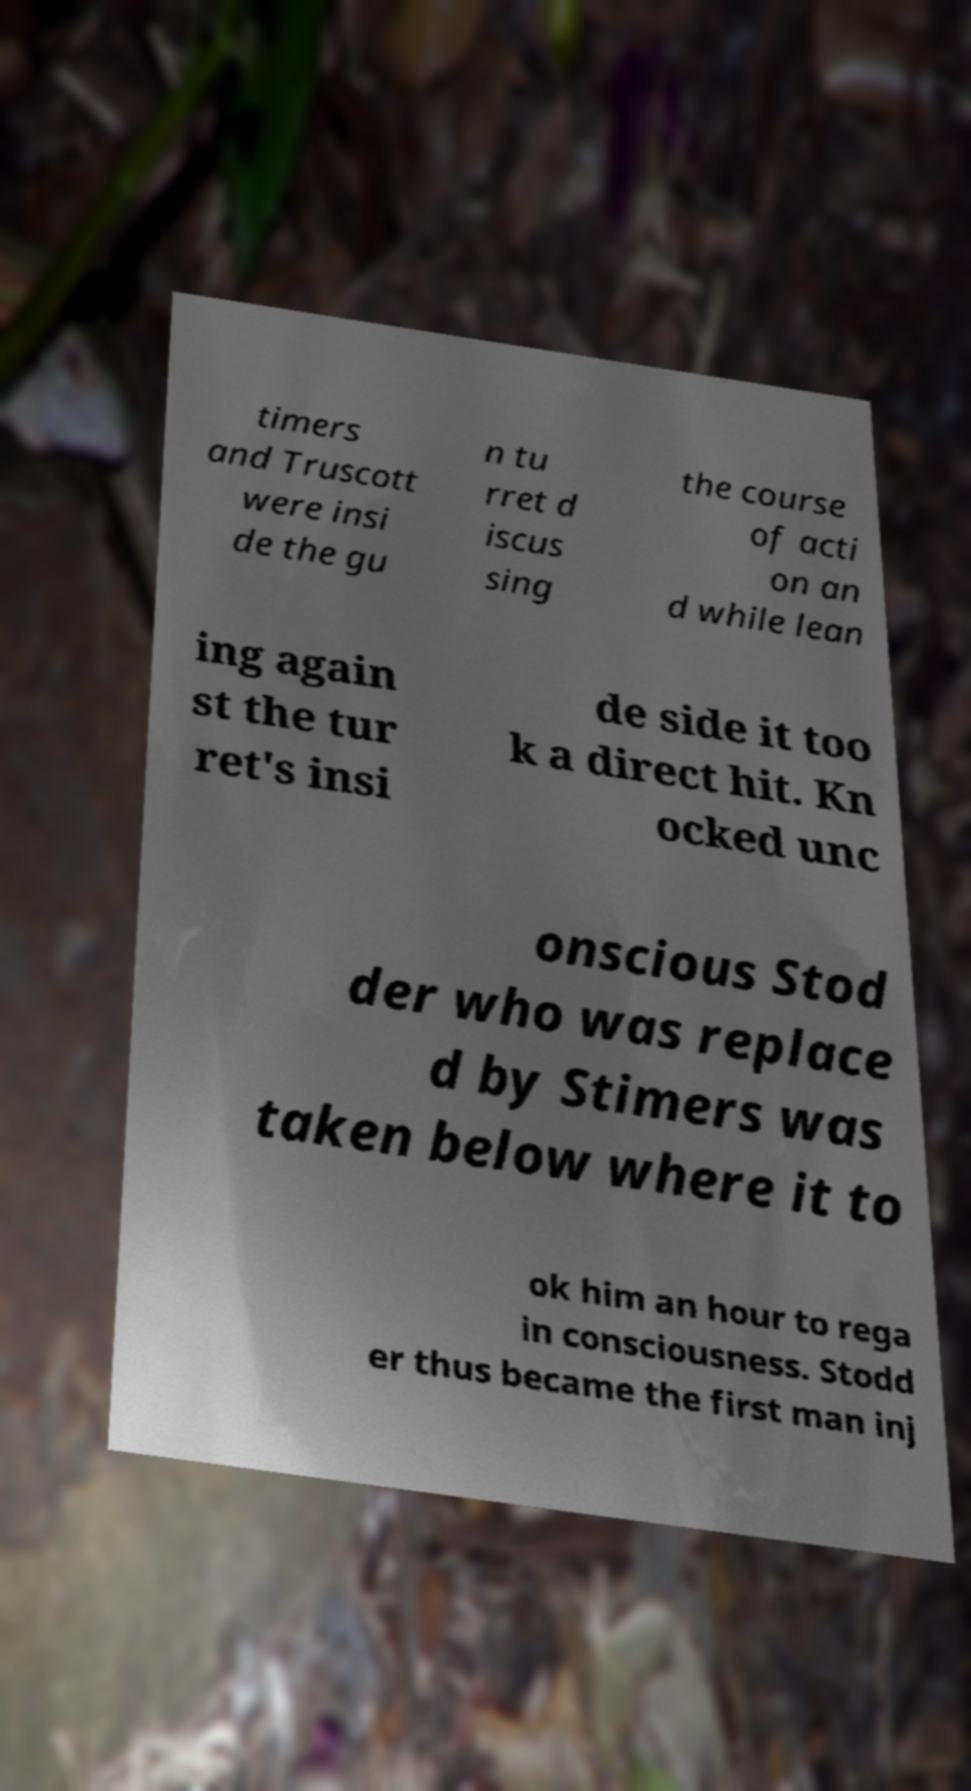Could you extract and type out the text from this image? timers and Truscott were insi de the gu n tu rret d iscus sing the course of acti on an d while lean ing again st the tur ret's insi de side it too k a direct hit. Kn ocked unc onscious Stod der who was replace d by Stimers was taken below where it to ok him an hour to rega in consciousness. Stodd er thus became the first man inj 